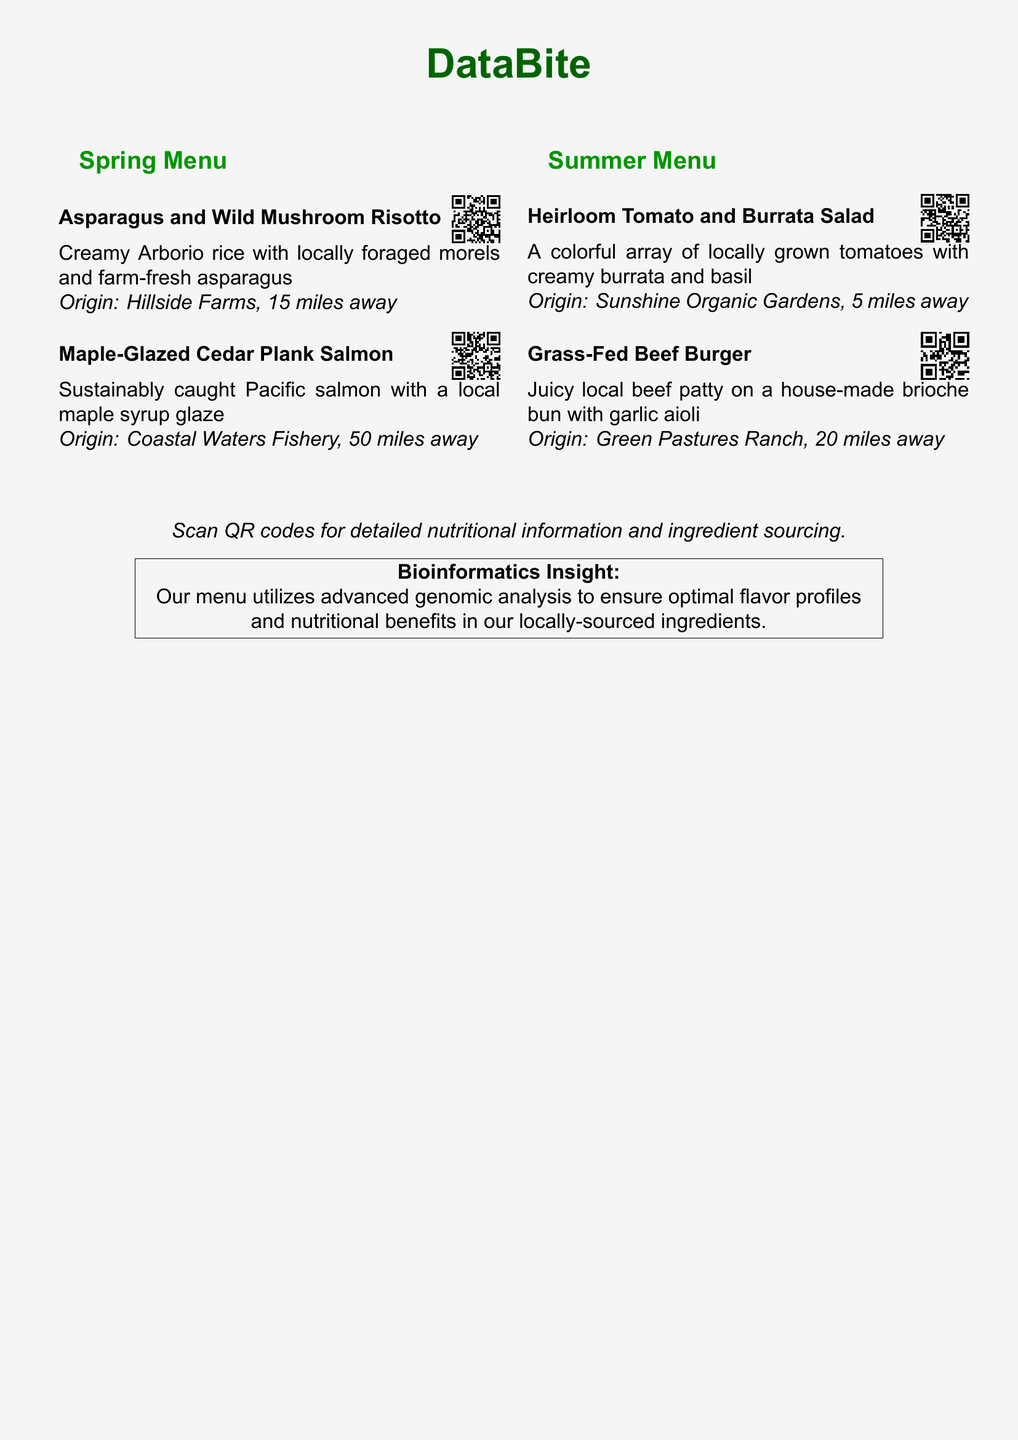What is the name of the first dish listed? The first dish under the Spring Menu is Asparagus and Wild Mushroom Risotto.
Answer: Asparagus and Wild Mushroom Risotto What ingredient is used to glaze the Cedar Plank Salmon? The Maple-Glazed Cedar Plank Salmon is glazed with local maple syrup.
Answer: Maple syrup How far away is Sunshine Organic Gardens? The origin of the Heirloom Tomato and Burrata Salad is listed as being 5 miles away.
Answer: 5 miles What is the type of beef used in the burger? The Grass-Fed Beef Burger is made from local grass-fed beef.
Answer: Grass-fed What is the main theme of the menu? The menu highlights seasonal dishes made with ingredients sourced locally.
Answer: Seasonal menu What type of analysis is mentioned in the bioinformatics insight? The insight states that advanced genomic analysis is utilized for flavor profiles and nutritional benefits.
Answer: Genomic analysis How many items are listed under the Summer Menu? There are two items listed under the Summer Menu.
Answer: Two What type of cheese is included in the Heirloom Tomato Salad? The Heirloom Tomato and Burrata Salad includes creamy burrata cheese.
Answer: Burrata What is the QR code intended for? The QR code links to detailed nutritional information and ingredient sourcing.
Answer: Nutritional information and ingredient sourcing 